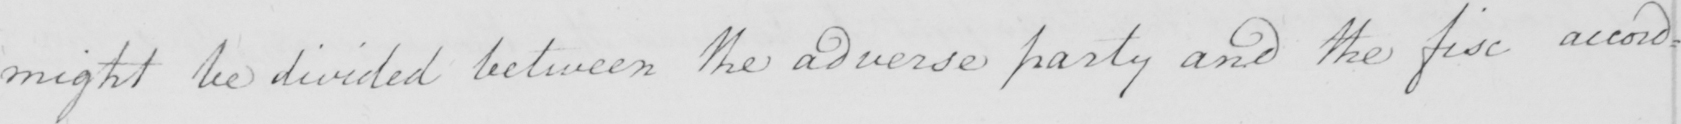Can you read and transcribe this handwriting? might be divided between the adverse party and the fisc accord= 